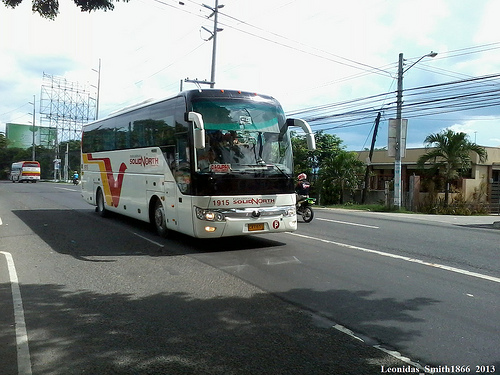Imagine a scenario where this street becomes a lively market in the morning. Describe the scene. In the morning, the street transforms into a bustling market. Vendors set up stalls along the pavement, selling fresh fruits, vegetables, and various goods. The aroma of street food wafts through the air, enticing passersby. Shoppers haggle with traders, adding to the vibrant sounds of the marketplace. The buses and motorcycles share the road with pedestrians, who are engrossed in the lively activities. 